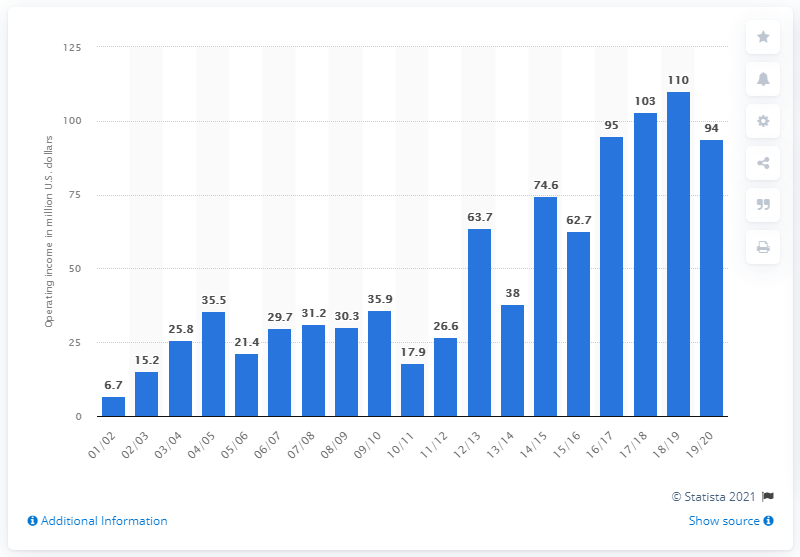Specify some key components in this picture. The operating income of the Houston Rockets in the 2019/20 season was $94 million. 